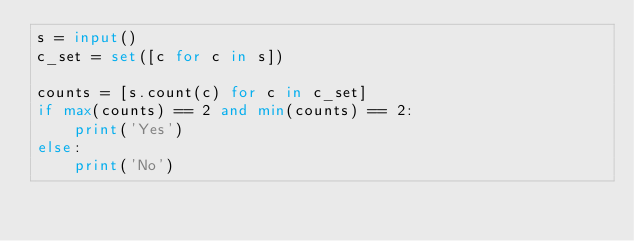<code> <loc_0><loc_0><loc_500><loc_500><_Python_>s = input()
c_set = set([c for c in s])

counts = [s.count(c) for c in c_set]
if max(counts) == 2 and min(counts) == 2:
    print('Yes')
else:
    print('No')
</code> 